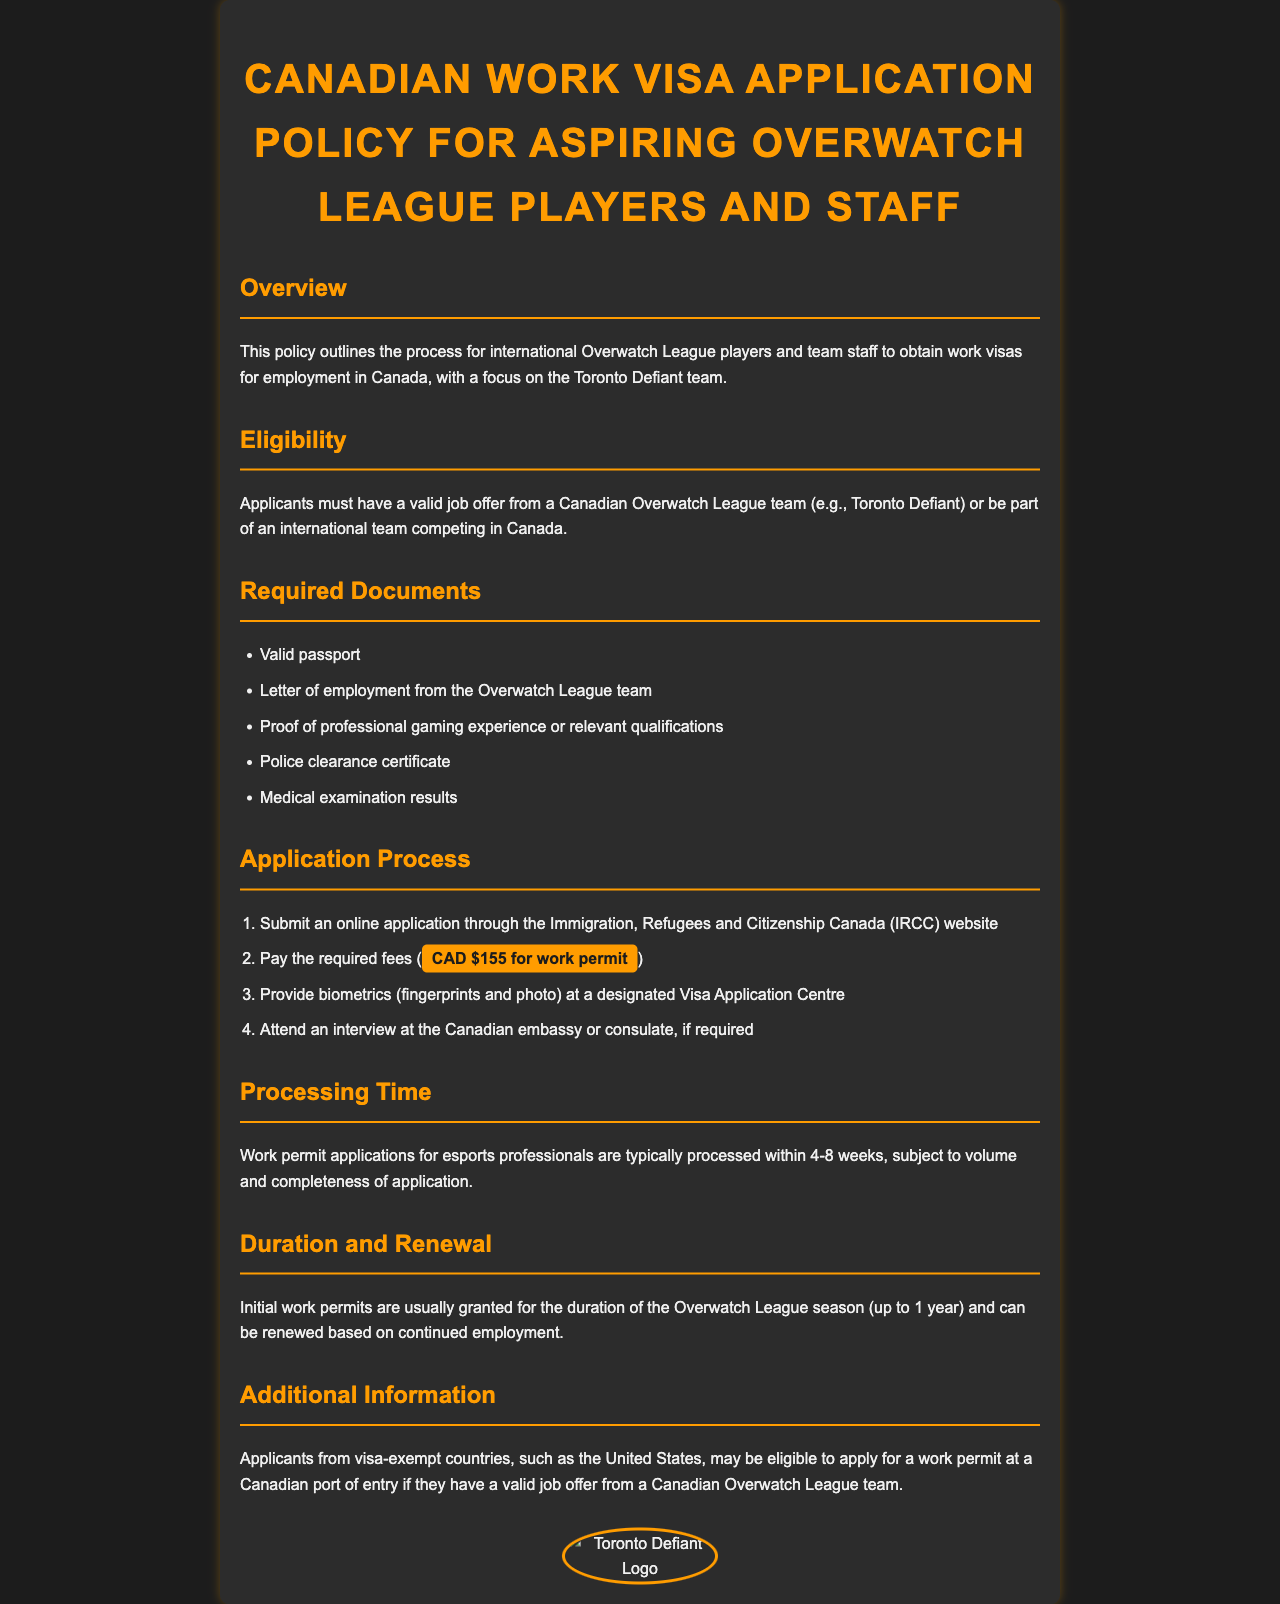What is the focus of this policy? The policy focuses on the process for international Overwatch League players and team staff to obtain work visas for employment in Canada.
Answer: Employment in Canada Who must applicants have a job offer from? Applicants must have a valid job offer from a Canadian Overwatch League team.
Answer: Canadian Overwatch League team What is one required document for the application? One of the required documents is a letter of employment from the Overwatch League team.
Answer: Letter of employment How much is the work permit fee? The required fee for the work permit is CAD $155.
Answer: CAD $155 What is the typical processing time for work permit applications? Work permit applications for esports professionals are typically processed within 4-8 weeks.
Answer: 4-8 weeks For how long are initial work permits usually granted? Initial work permits are usually granted for the duration of the Overwatch League season, which is up to 1 year.
Answer: Up to 1 year Can applicants from visa-exempt countries apply at a Canadian port of entry? Yes, applicants from visa-exempt countries may be eligible to apply for a work permit at a Canadian port of entry.
Answer: Yes 